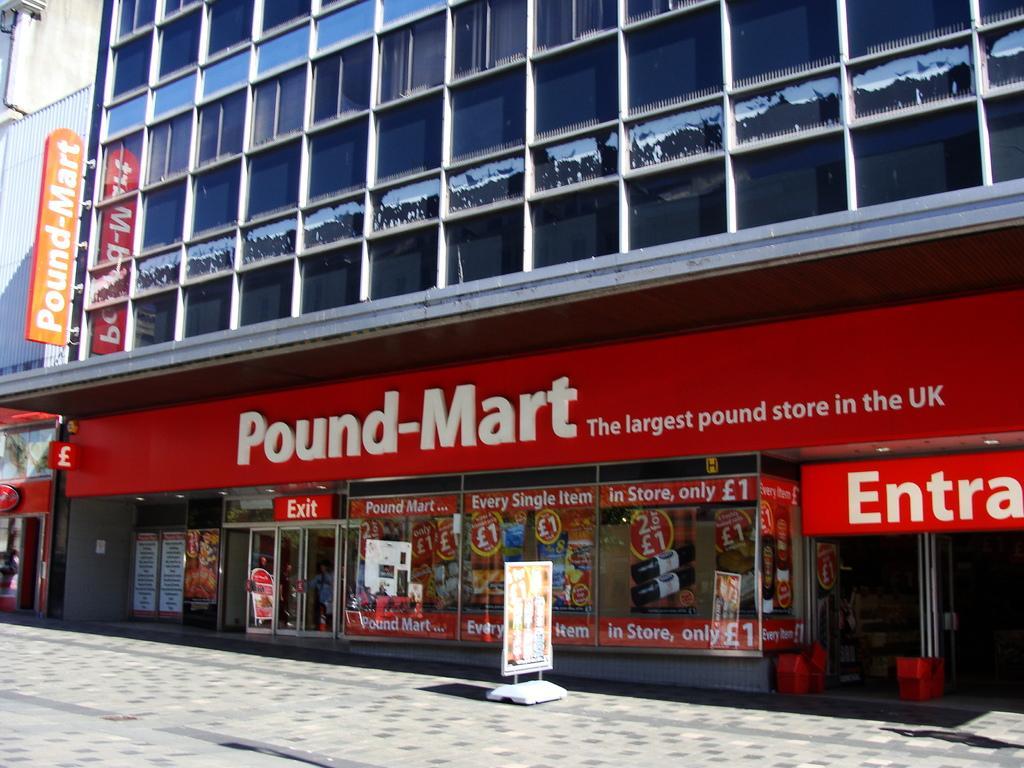Can you describe this image briefly? In the center of the image we can see one building, windows, banners, glass doors, road and a few other objects. On the building, it is written as "Pound Mart". 